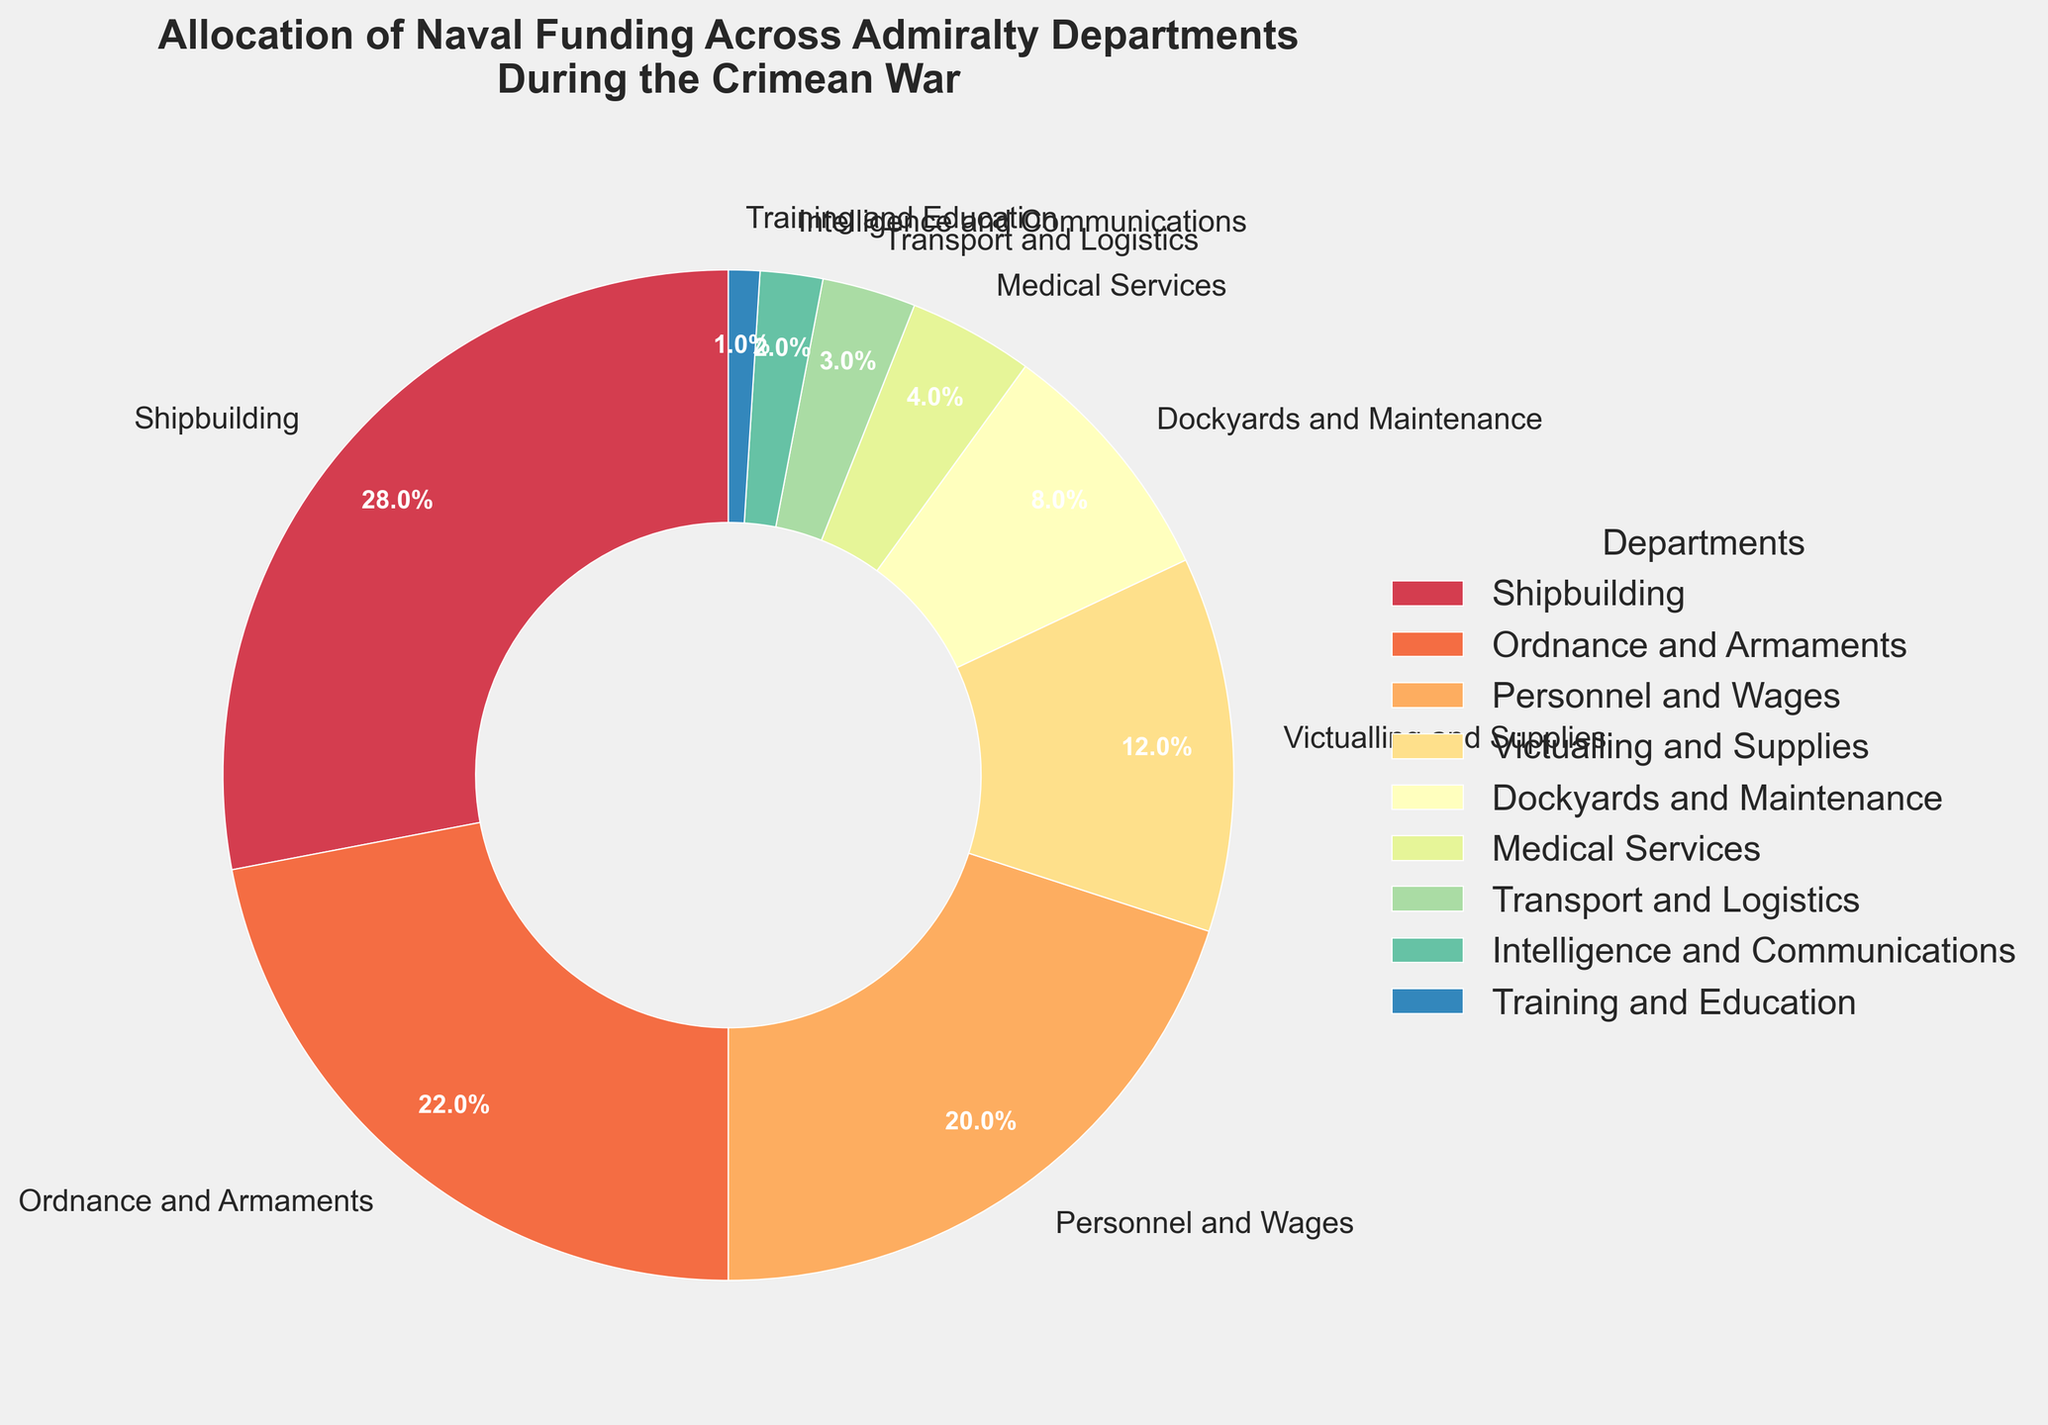Which department received the highest percentage of naval funding? The figure shows that the department with the largest section in the pie chart is Shipbuilding, indicating it receives the highest percentage of funding.
Answer: Shipbuilding Which departments received a combined total of 30% of naval funding? The figure shows the percentages for each department. Adding the percentages for Dockyards and Maintenance (8%), Medical Services (4%), Transport and Logistics (3%), Intelligence and Communications (2%), and Training and Education (1%) gives 8 + 4 + 3 + 2 + 1 = 18%. Adding Victualling and Supplies (12%) reaches 30%.
Answer: Dockyards and Maintenance, Medical Services, Transport and Logistics, Intelligence and Communications, Training and Education, and Victualling and Supplies What is the difference in naval funding between Ordnance and Armaments and Personnel and Wages? From the figure, Ordnance and Armaments receives 22% and Personnel and Wages receives 20%. The difference is 22 - 20 = 2%.
Answer: 2% Which department has the smallest share of naval funding? The figure shows the smallest section in the pie chart belongs to Training and Education, indicating it receives the smallest share of funding.
Answer: Training and Education What percentage of naval funding is allocated to departments other than Shipbuilding and Ordnance and Armaments? The total percentage for all departments is 100%. Subtracting the percentages for Shipbuilding (28%) and Ordnance and Armaments (22%) gives 100 - 28 - 22 = 50%.
Answer: 50% Which two departments together receive more funding than Ordnance and Armaments but less than Shipbuilding? The figure indicates Ordnance and Armaments receives 22% and Shipbuilding receives 28%. Personnel and Wages (20%) and Victualling and Supplies (12%) together receive 20 + 12 = 32%, which is more than 22% but less than 28%.
Answer: Personnel and Wages and Victualling and Supplies How does the percentage of funding for Dockyards and Maintenance compare to the percentage for Medical Services? From the figure, Dockyards and Maintenance receives 8% while Medical Services receives 4%. Therefore, Dockyards and Maintenance receives twice the funding of Medical Services.
Answer: Twice as much Is the funding for Transport and Logistics greater or less than half of Victualling and Supplies? The figure shows Transport and Logistics at 3% and Victualling and Supplies at 12%. Half of 12% is 6%, and 3% is less than 6%.
Answer: Less What is the combined percentage of funding for the three smallest departments? The figure shows the three smallest departments are Training and Education (1%), Intelligence and Communications (2%), and Transport and Logistics (3%). Adding these together gives 1 + 2 + 3 = 6%.
Answer: 6% 